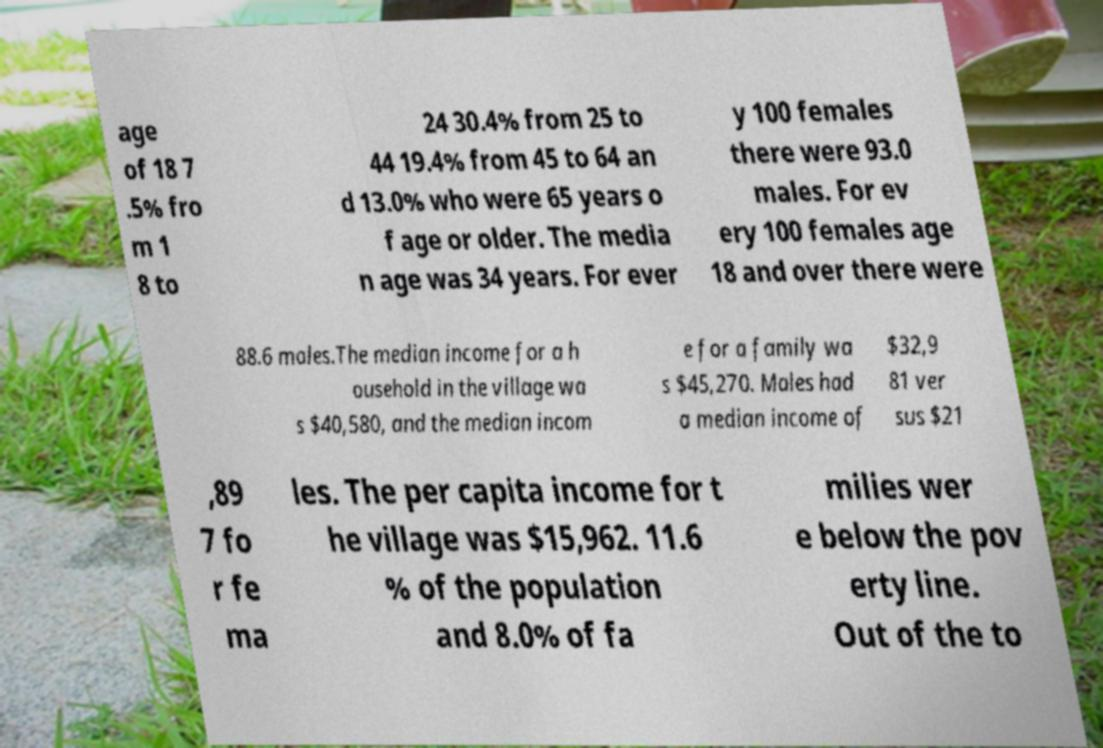Could you assist in decoding the text presented in this image and type it out clearly? age of 18 7 .5% fro m 1 8 to 24 30.4% from 25 to 44 19.4% from 45 to 64 an d 13.0% who were 65 years o f age or older. The media n age was 34 years. For ever y 100 females there were 93.0 males. For ev ery 100 females age 18 and over there were 88.6 males.The median income for a h ousehold in the village wa s $40,580, and the median incom e for a family wa s $45,270. Males had a median income of $32,9 81 ver sus $21 ,89 7 fo r fe ma les. The per capita income for t he village was $15,962. 11.6 % of the population and 8.0% of fa milies wer e below the pov erty line. Out of the to 